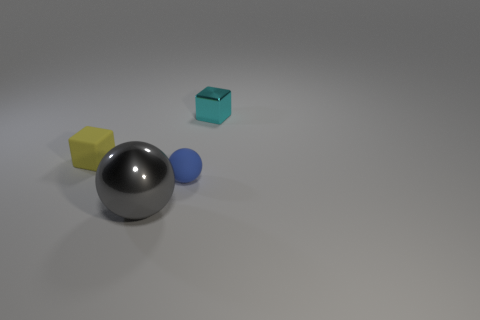What number of other things are there of the same size as the gray metallic sphere?
Ensure brevity in your answer.  0. What shape is the tiny matte object that is in front of the small yellow cube?
Make the answer very short. Sphere. The shiny thing in front of the tiny rubber sphere that is behind the gray metallic thing is what shape?
Offer a terse response. Sphere. Are there any tiny blue things of the same shape as the large gray metal object?
Your answer should be very brief. Yes. What is the shape of the cyan object that is the same size as the blue matte sphere?
Your response must be concise. Cube. There is a metallic object in front of the block to the right of the large gray ball; are there any matte things right of it?
Keep it short and to the point. Yes. Are there any cyan metallic blocks of the same size as the blue matte object?
Provide a succinct answer. Yes. There is a shiny thing that is behind the small rubber cube; how big is it?
Keep it short and to the point. Small. The tiny thing behind the small cube that is in front of the metal object behind the gray shiny object is what color?
Provide a short and direct response. Cyan. The matte object to the right of the tiny cube that is on the left side of the blue sphere is what color?
Your response must be concise. Blue. 